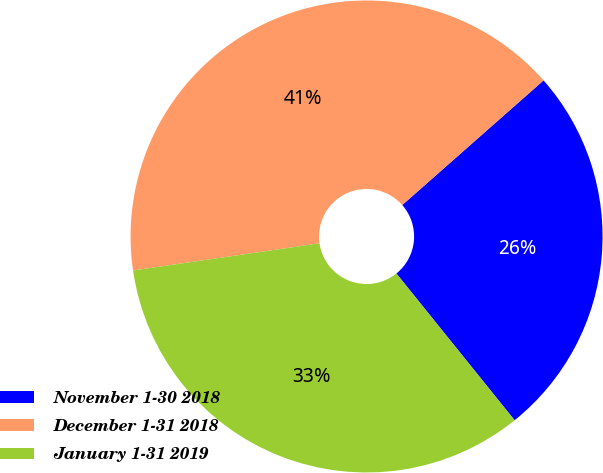Convert chart to OTSL. <chart><loc_0><loc_0><loc_500><loc_500><pie_chart><fcel>November 1-30 2018<fcel>December 1-31 2018<fcel>January 1-31 2019<nl><fcel>25.71%<fcel>40.8%<fcel>33.49%<nl></chart> 